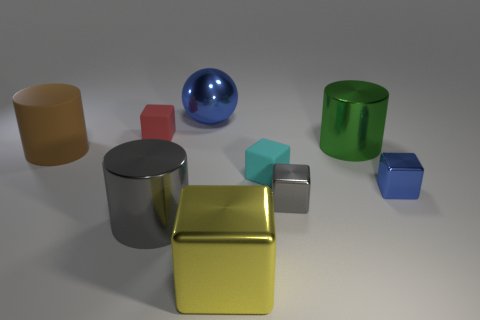Does the gray cylinder have the same size as the gray thing on the right side of the big ball? The gray cylinder appears slightly taller and wider than the gray cube on the right side of the large blue sphere, suggesting that they do not have the same size. 